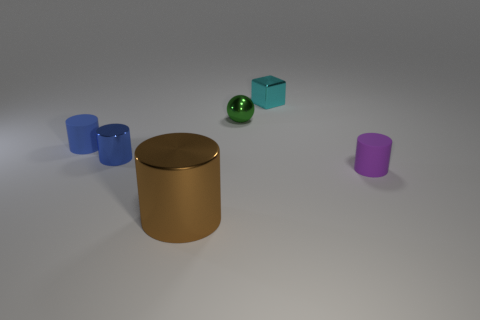There is a small matte object behind the purple matte cylinder; are there any metal cubes in front of it?
Give a very brief answer. No. There is a tiny cylinder to the right of the small shiny thing right of the tiny green thing; are there any small things left of it?
Make the answer very short. Yes. There is a metal object on the right side of the tiny green ball; does it have the same shape as the rubber object that is on the right side of the block?
Your response must be concise. No. What is the color of the ball that is the same material as the large brown thing?
Your response must be concise. Green. Are there fewer metal objects that are behind the small purple object than green rubber cylinders?
Your response must be concise. No. How big is the matte object that is on the right side of the matte cylinder left of the cylinder that is on the right side of the small shiny block?
Provide a short and direct response. Small. Is the material of the small cyan block that is to the right of the blue matte cylinder the same as the large brown object?
Offer a very short reply. Yes. There is another small cylinder that is the same color as the tiny metal cylinder; what is its material?
Offer a very short reply. Rubber. Is there anything else that is the same shape as the brown shiny thing?
Give a very brief answer. Yes. What number of things are either tiny blue rubber objects or purple things?
Offer a terse response. 2. 